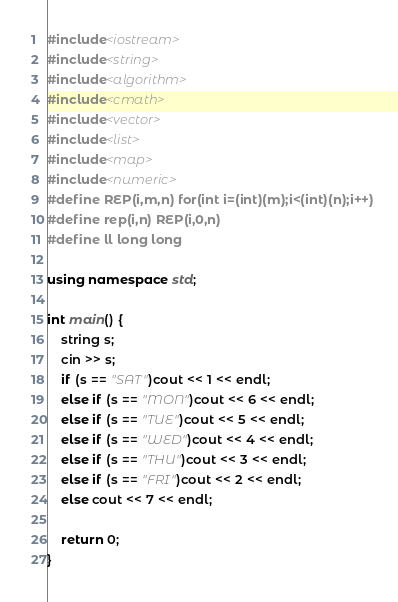<code> <loc_0><loc_0><loc_500><loc_500><_C++_>#include<iostream>
#include<string>
#include<algorithm>
#include<cmath>
#include<vector>
#include<list>
#include<map>
#include<numeric>
#define REP(i,m,n) for(int i=(int)(m);i<(int)(n);i++)
#define rep(i,n) REP(i,0,n)
#define ll long long

using namespace std;

int main() {
	string s;
	cin >> s;
	if (s == "SAT")cout << 1 << endl;
	else if (s == "MON")cout << 6 << endl;
	else if (s == "TUE")cout << 5 << endl;
	else if (s == "WED")cout << 4 << endl;
	else if (s == "THU")cout << 3 << endl;
	else if (s == "FRI")cout << 2 << endl;
	else cout << 7 << endl;

	return 0;
}
</code> 